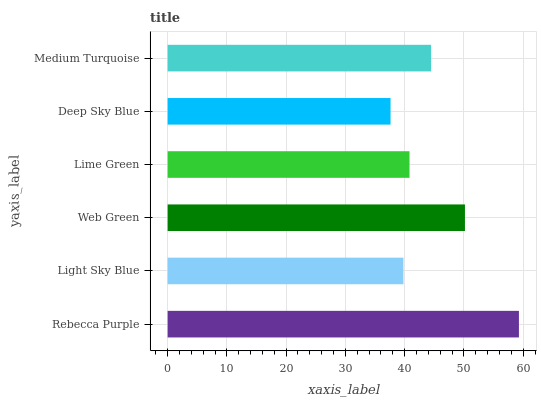Is Deep Sky Blue the minimum?
Answer yes or no. Yes. Is Rebecca Purple the maximum?
Answer yes or no. Yes. Is Light Sky Blue the minimum?
Answer yes or no. No. Is Light Sky Blue the maximum?
Answer yes or no. No. Is Rebecca Purple greater than Light Sky Blue?
Answer yes or no. Yes. Is Light Sky Blue less than Rebecca Purple?
Answer yes or no. Yes. Is Light Sky Blue greater than Rebecca Purple?
Answer yes or no. No. Is Rebecca Purple less than Light Sky Blue?
Answer yes or no. No. Is Medium Turquoise the high median?
Answer yes or no. Yes. Is Lime Green the low median?
Answer yes or no. Yes. Is Light Sky Blue the high median?
Answer yes or no. No. Is Medium Turquoise the low median?
Answer yes or no. No. 